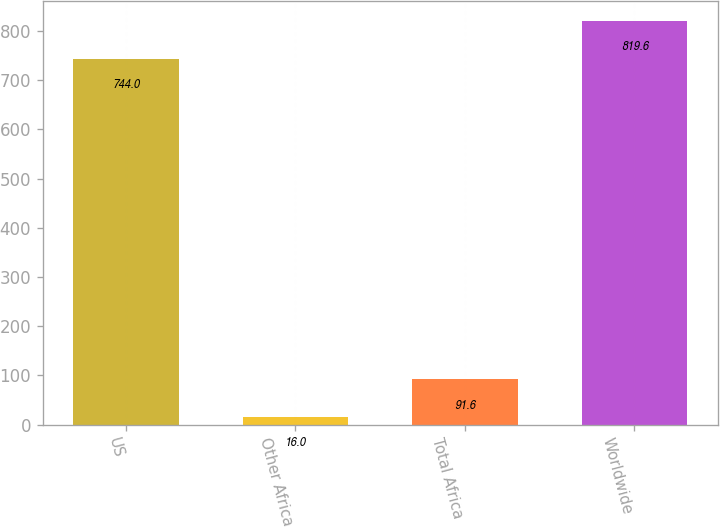Convert chart to OTSL. <chart><loc_0><loc_0><loc_500><loc_500><bar_chart><fcel>US<fcel>Other Africa<fcel>Total Africa<fcel>Worldwide<nl><fcel>744<fcel>16<fcel>91.6<fcel>819.6<nl></chart> 